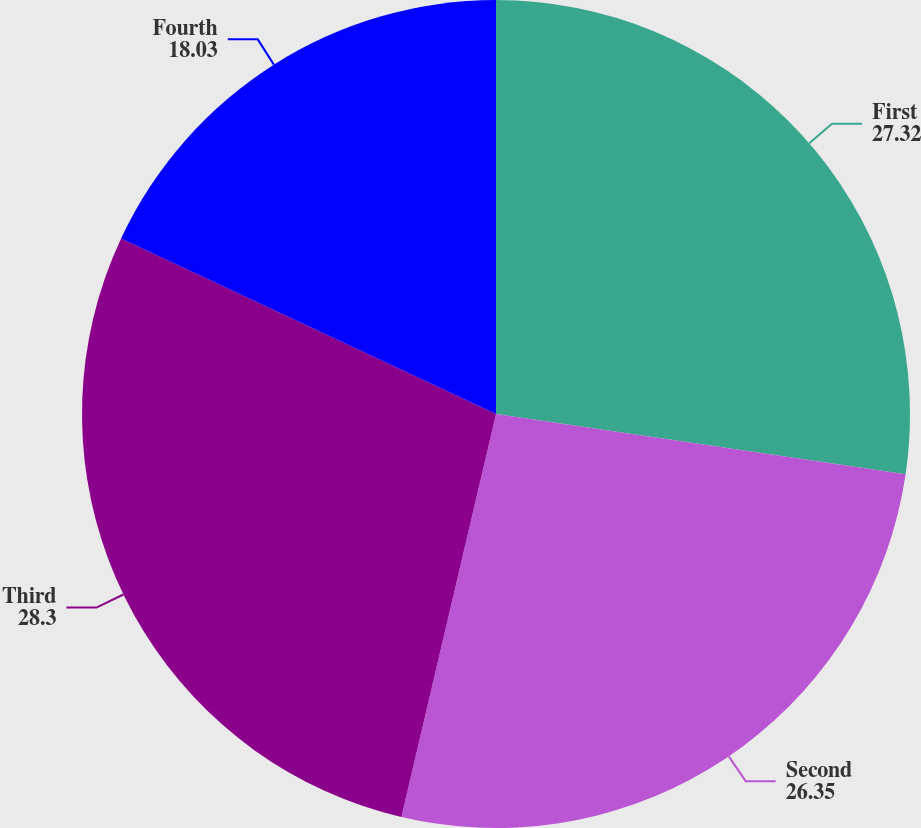Convert chart to OTSL. <chart><loc_0><loc_0><loc_500><loc_500><pie_chart><fcel>First<fcel>Second<fcel>Third<fcel>Fourth<nl><fcel>27.32%<fcel>26.35%<fcel>28.3%<fcel>18.03%<nl></chart> 